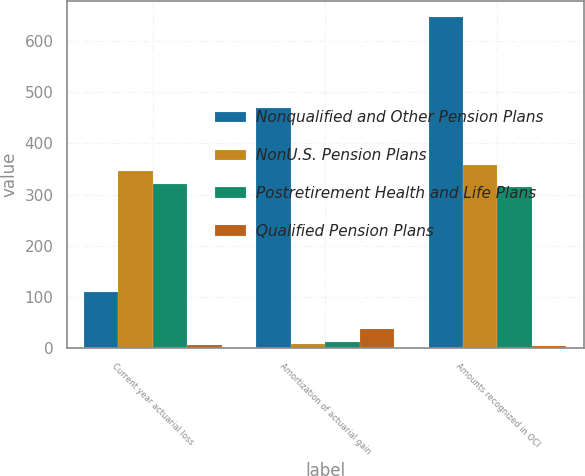Convert chart to OTSL. <chart><loc_0><loc_0><loc_500><loc_500><stacked_bar_chart><ecel><fcel>Current year actuarial loss<fcel>Amortization of actuarial gain<fcel>Amounts recognized in OCI<nl><fcel>Nonqualified and Other Pension Plans<fcel>110<fcel>469<fcel>646<nl><fcel>NonU.S. Pension Plans<fcel>347<fcel>9<fcel>358<nl><fcel>Postretirement Health and Life Plans<fcel>321<fcel>12<fcel>316<nl><fcel>Qualified Pension Plans<fcel>7<fcel>38<fcel>5<nl></chart> 